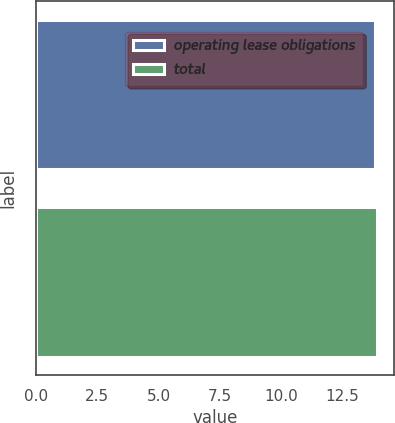<chart> <loc_0><loc_0><loc_500><loc_500><bar_chart><fcel>operating lease obligations<fcel>total<nl><fcel>13.8<fcel>13.9<nl></chart> 